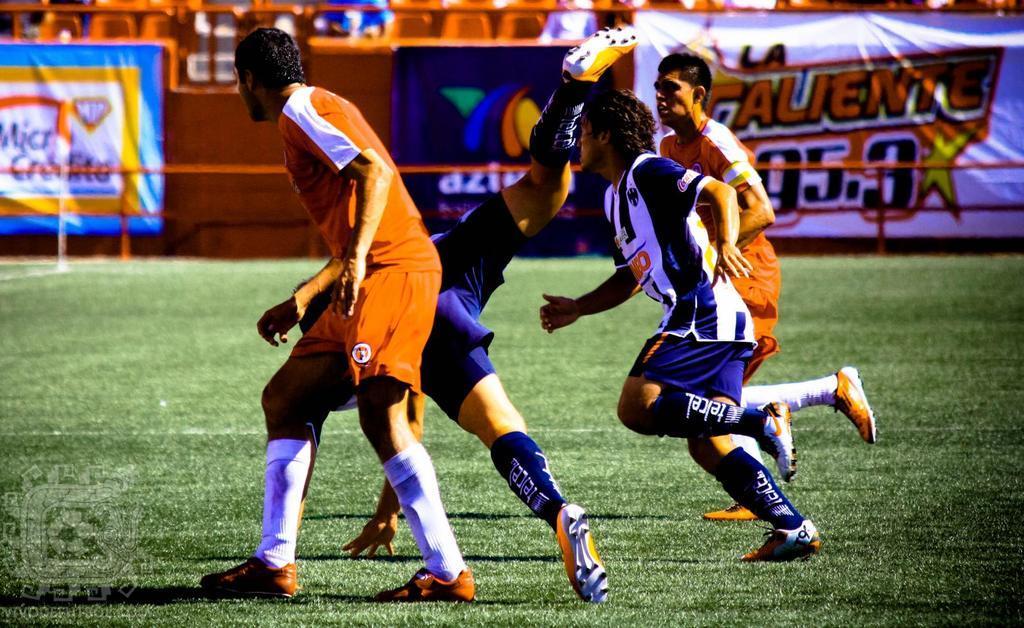Please provide a concise description of this image. In this image we can see some group of persons wearing orange and blue color dress playing some sport and in the background of the image there is orange color fencing to which there are some posters attached. 